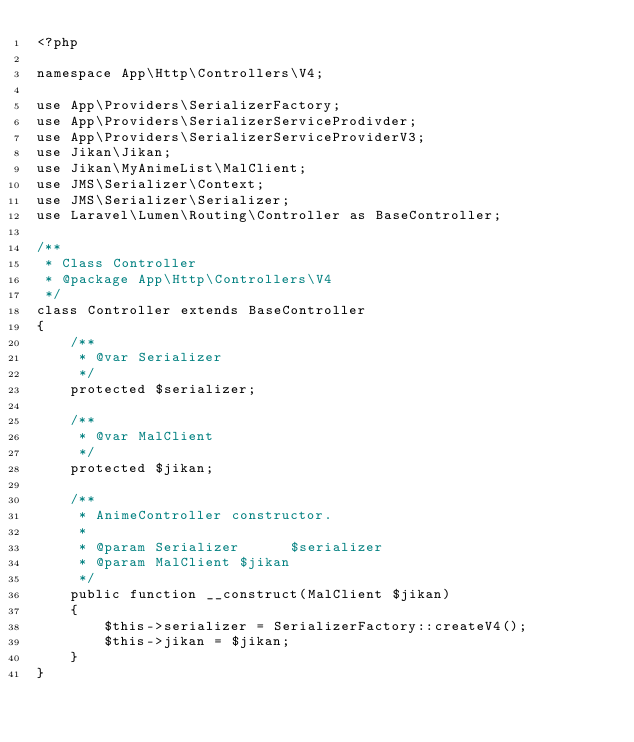<code> <loc_0><loc_0><loc_500><loc_500><_PHP_><?php

namespace App\Http\Controllers\V4;

use App\Providers\SerializerFactory;
use App\Providers\SerializerServiceProdivder;
use App\Providers\SerializerServiceProviderV3;
use Jikan\Jikan;
use Jikan\MyAnimeList\MalClient;
use JMS\Serializer\Context;
use JMS\Serializer\Serializer;
use Laravel\Lumen\Routing\Controller as BaseController;

/**
 * Class Controller
 * @package App\Http\Controllers\V4
 */
class Controller extends BaseController
{
    /**
     * @var Serializer
     */
    protected $serializer;

    /**
     * @var MalClient
     */
    protected $jikan;

    /**
     * AnimeController constructor.
     *
     * @param Serializer      $serializer
     * @param MalClient $jikan
     */
    public function __construct(MalClient $jikan)
    {
        $this->serializer = SerializerFactory::createV4();
        $this->jikan = $jikan;
    }
}
</code> 